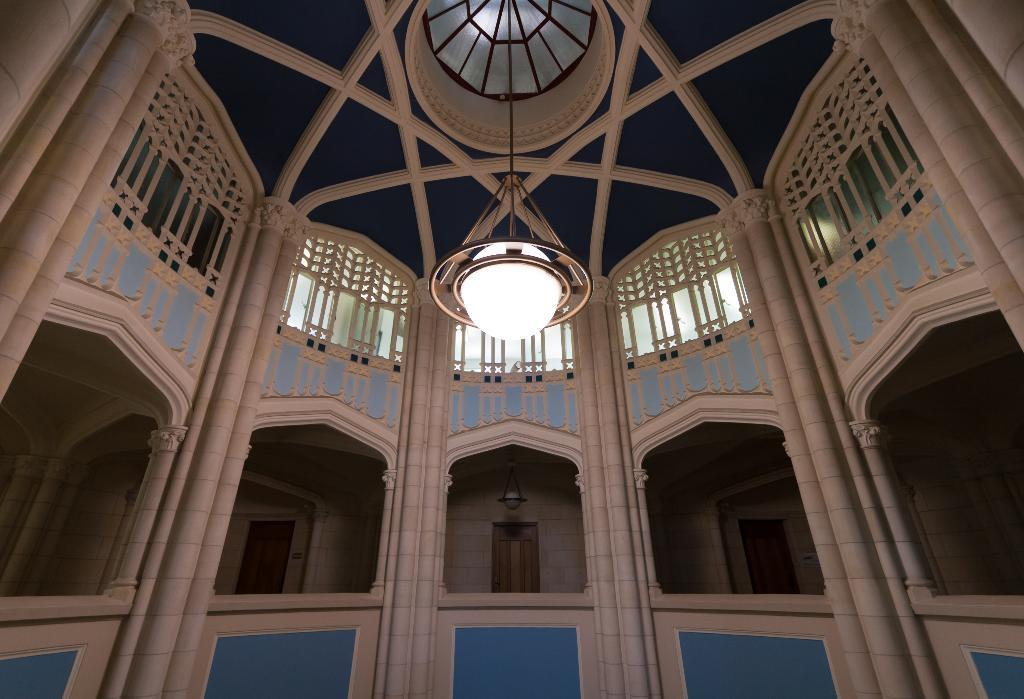What type of view is shown in the image? The image shows an inner view of a building. Can you describe any specific features of the building's interior? There is a light hanging from the roof in the image. What color is the arm of the person standing near the light? There is no person or arm visible in the image; it only shows an inner view of a building with a light hanging from the roof. 